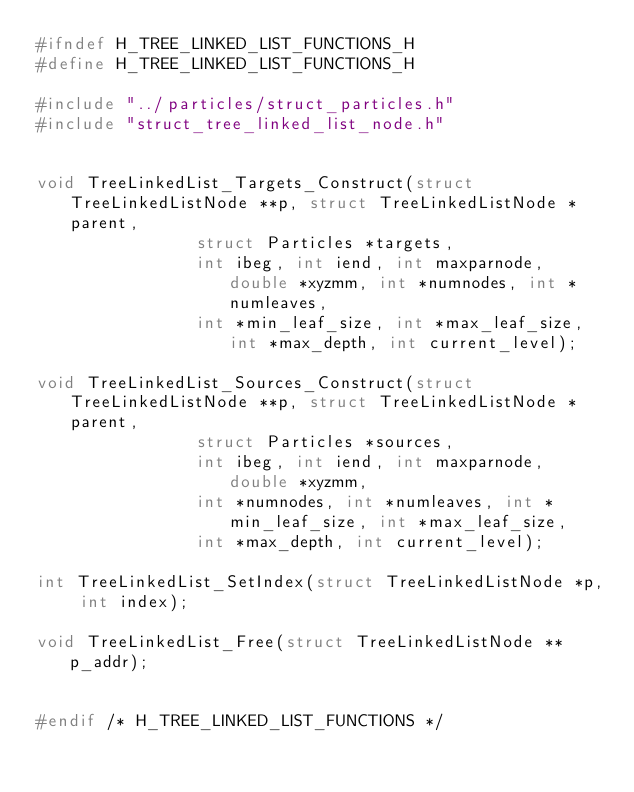Convert code to text. <code><loc_0><loc_0><loc_500><loc_500><_C_>#ifndef H_TREE_LINKED_LIST_FUNCTIONS_H
#define H_TREE_LINKED_LIST_FUNCTIONS_H

#include "../particles/struct_particles.h"
#include "struct_tree_linked_list_node.h"


void TreeLinkedList_Targets_Construct(struct TreeLinkedListNode **p, struct TreeLinkedListNode *parent,
                struct Particles *targets,
                int ibeg, int iend, int maxparnode, double *xyzmm, int *numnodes, int *numleaves,
                int *min_leaf_size, int *max_leaf_size, int *max_depth, int current_level);

void TreeLinkedList_Sources_Construct(struct TreeLinkedListNode **p, struct TreeLinkedListNode *parent,
                struct Particles *sources,
                int ibeg, int iend, int maxparnode, double *xyzmm,
                int *numnodes, int *numleaves, int *min_leaf_size, int *max_leaf_size,
                int *max_depth, int current_level);

int TreeLinkedList_SetIndex(struct TreeLinkedListNode *p, int index);

void TreeLinkedList_Free(struct TreeLinkedListNode **p_addr);


#endif /* H_TREE_LINKED_LIST_FUNCTIONS */
</code> 